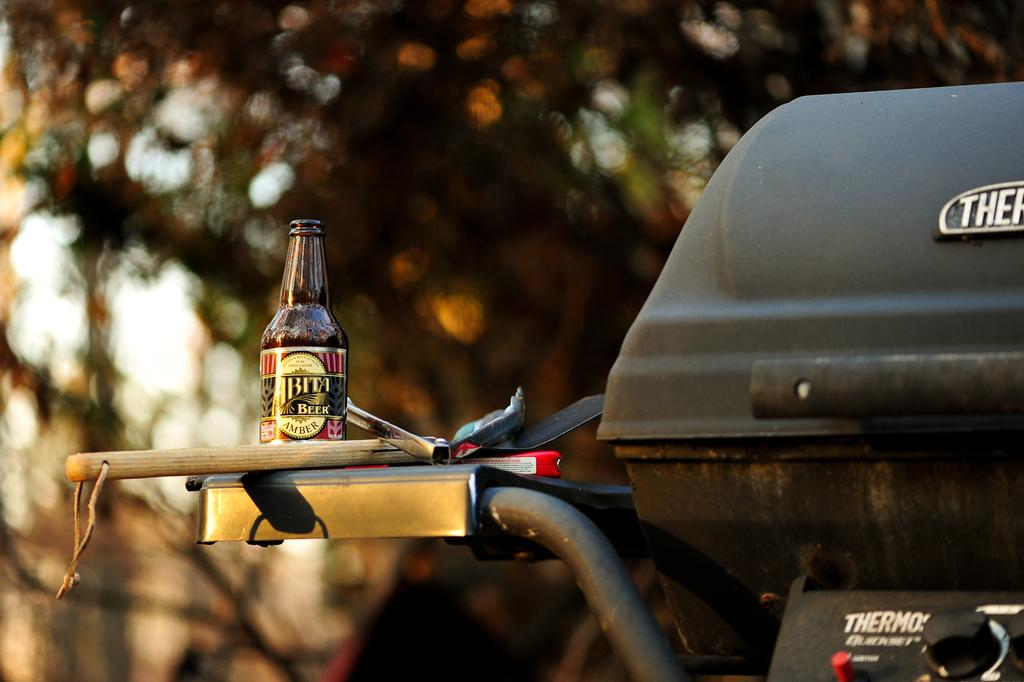What is the main subject in the center of the image? There is a vehicle in the center of the image. What can be seen on the vehicle? There is a bottle and some objects on the vehicle. What is visible in the background of the image? There are trees in the background of the image. How many women are playing volleyball in the image? There are no women or volleyball present in the image. What type of bag is visible on the vehicle? There is no bag visible on the vehicle in the image. 